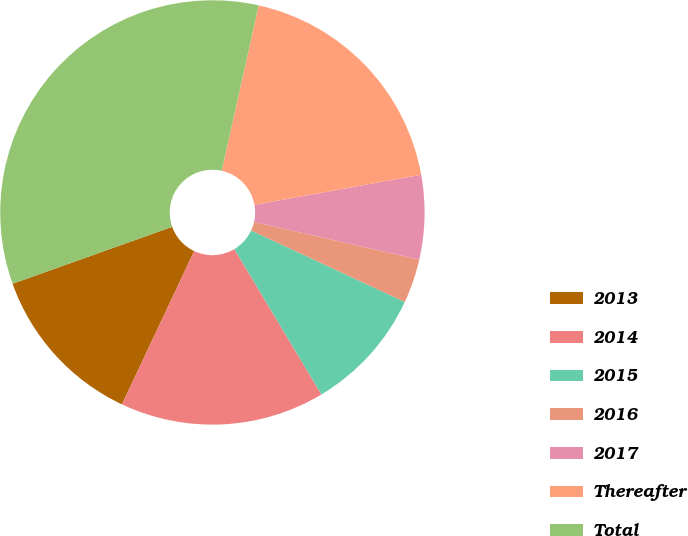<chart> <loc_0><loc_0><loc_500><loc_500><pie_chart><fcel>2013<fcel>2014<fcel>2015<fcel>2016<fcel>2017<fcel>Thereafter<fcel>Total<nl><fcel>12.54%<fcel>15.6%<fcel>9.48%<fcel>3.36%<fcel>6.42%<fcel>18.66%<fcel>33.96%<nl></chart> 